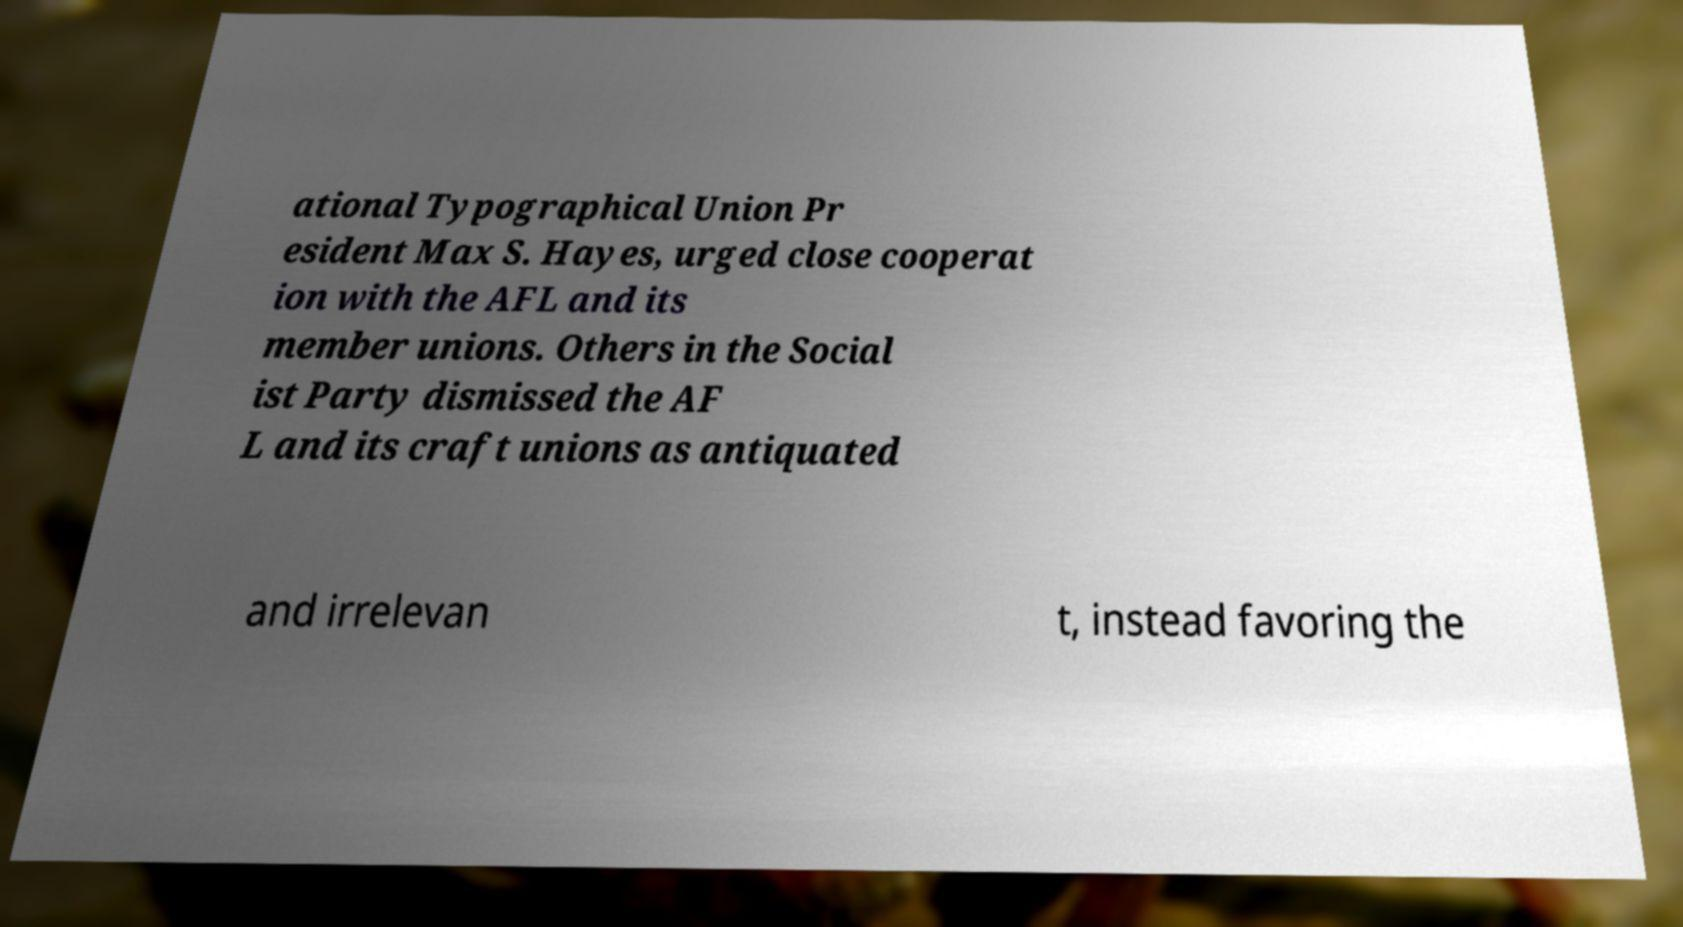Could you assist in decoding the text presented in this image and type it out clearly? ational Typographical Union Pr esident Max S. Hayes, urged close cooperat ion with the AFL and its member unions. Others in the Social ist Party dismissed the AF L and its craft unions as antiquated and irrelevan t, instead favoring the 